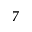Convert formula to latex. <formula><loc_0><loc_0><loc_500><loc_500>7</formula> 